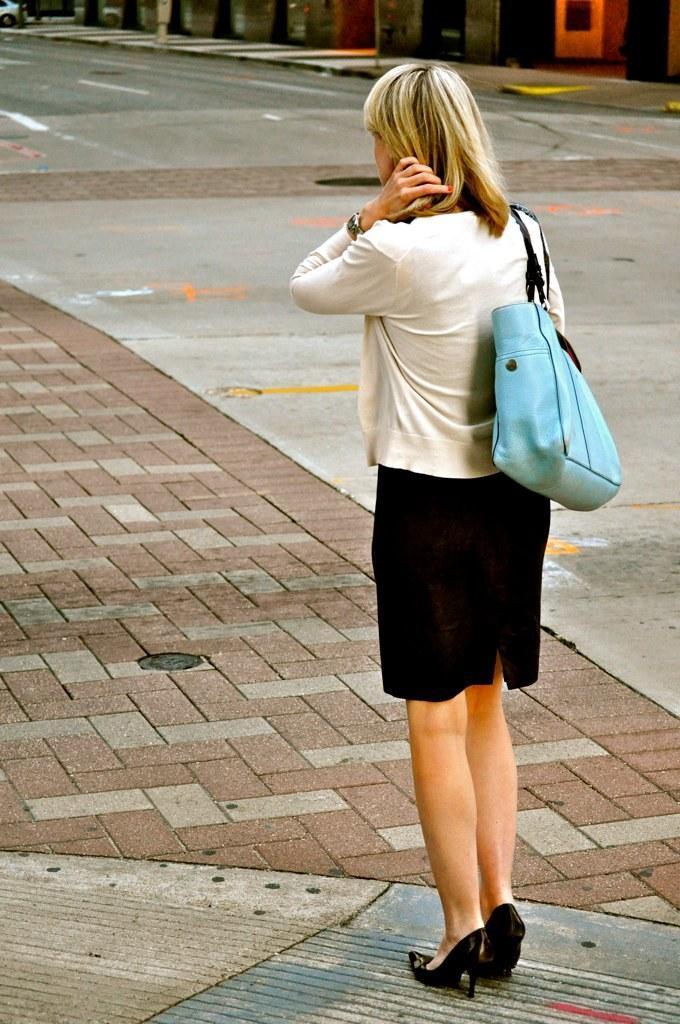Can you describe this image briefly? This picture is clicked outside. On the right we can see a person wearing a sling bag and standing on the ground. In the background we can see a vehicle and some other objects. 